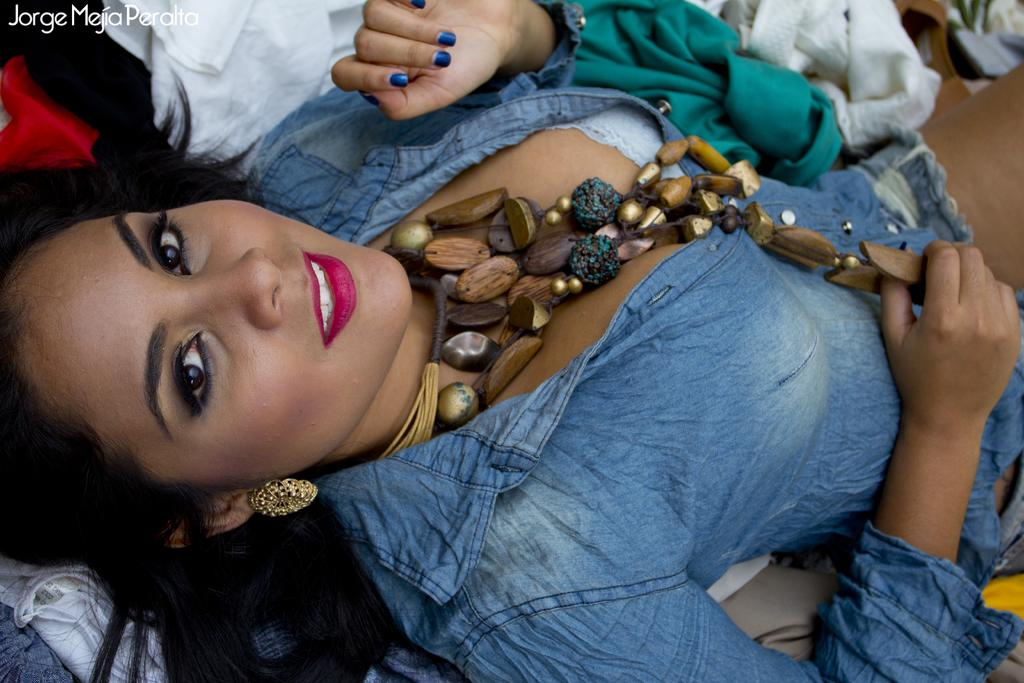Who is the main subject in the image? There is a woman in the image. What is the woman laying on? The woman is laying on clothes. What color is the shirt the woman is wearing? The woman is wearing a blue shirt. What type of accessory is the woman wearing? The woman is wearing a chain made up of wooden particles. What is the weather like in the image? The provided facts do not mention any information about the weather, so it cannot be determined from the image. 